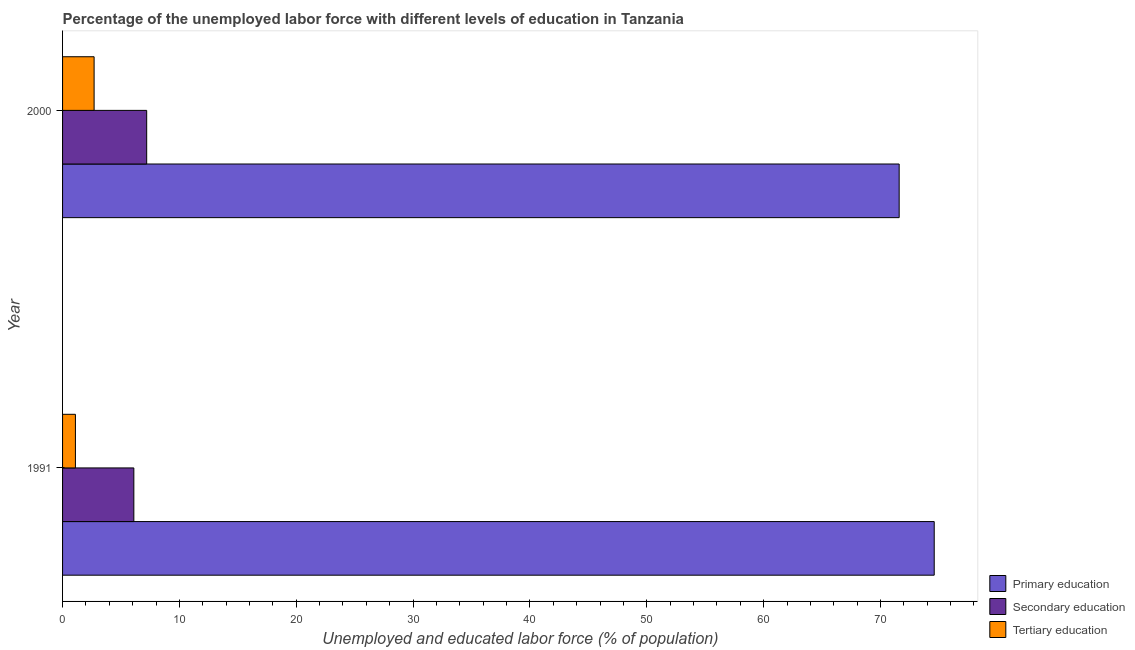How many different coloured bars are there?
Offer a very short reply. 3. How many groups of bars are there?
Make the answer very short. 2. Are the number of bars per tick equal to the number of legend labels?
Your answer should be compact. Yes. How many bars are there on the 2nd tick from the top?
Provide a succinct answer. 3. How many bars are there on the 1st tick from the bottom?
Give a very brief answer. 3. What is the percentage of labor force who received tertiary education in 2000?
Your response must be concise. 2.7. Across all years, what is the maximum percentage of labor force who received primary education?
Your answer should be compact. 74.6. Across all years, what is the minimum percentage of labor force who received tertiary education?
Your response must be concise. 1.1. What is the total percentage of labor force who received tertiary education in the graph?
Offer a very short reply. 3.8. What is the difference between the percentage of labor force who received primary education in 1991 and that in 2000?
Your response must be concise. 3. What is the difference between the percentage of labor force who received tertiary education in 1991 and the percentage of labor force who received secondary education in 2000?
Offer a very short reply. -6.1. What is the average percentage of labor force who received tertiary education per year?
Offer a terse response. 1.9. In the year 2000, what is the difference between the percentage of labor force who received primary education and percentage of labor force who received secondary education?
Offer a terse response. 64.4. In how many years, is the percentage of labor force who received secondary education greater than 18 %?
Provide a succinct answer. 0. What is the ratio of the percentage of labor force who received primary education in 1991 to that in 2000?
Give a very brief answer. 1.04. In how many years, is the percentage of labor force who received primary education greater than the average percentage of labor force who received primary education taken over all years?
Offer a terse response. 1. What does the 1st bar from the top in 2000 represents?
Your answer should be compact. Tertiary education. Is it the case that in every year, the sum of the percentage of labor force who received primary education and percentage of labor force who received secondary education is greater than the percentage of labor force who received tertiary education?
Your answer should be very brief. Yes. What is the difference between two consecutive major ticks on the X-axis?
Your answer should be very brief. 10. Are the values on the major ticks of X-axis written in scientific E-notation?
Make the answer very short. No. Does the graph contain grids?
Offer a terse response. No. Where does the legend appear in the graph?
Keep it short and to the point. Bottom right. How many legend labels are there?
Keep it short and to the point. 3. What is the title of the graph?
Your answer should be compact. Percentage of the unemployed labor force with different levels of education in Tanzania. Does "Wage workers" appear as one of the legend labels in the graph?
Your answer should be compact. No. What is the label or title of the X-axis?
Offer a very short reply. Unemployed and educated labor force (% of population). What is the label or title of the Y-axis?
Offer a very short reply. Year. What is the Unemployed and educated labor force (% of population) in Primary education in 1991?
Ensure brevity in your answer.  74.6. What is the Unemployed and educated labor force (% of population) of Secondary education in 1991?
Give a very brief answer. 6.1. What is the Unemployed and educated labor force (% of population) in Tertiary education in 1991?
Your answer should be compact. 1.1. What is the Unemployed and educated labor force (% of population) in Primary education in 2000?
Ensure brevity in your answer.  71.6. What is the Unemployed and educated labor force (% of population) in Secondary education in 2000?
Ensure brevity in your answer.  7.2. What is the Unemployed and educated labor force (% of population) of Tertiary education in 2000?
Provide a succinct answer. 2.7. Across all years, what is the maximum Unemployed and educated labor force (% of population) in Primary education?
Your response must be concise. 74.6. Across all years, what is the maximum Unemployed and educated labor force (% of population) of Secondary education?
Offer a terse response. 7.2. Across all years, what is the maximum Unemployed and educated labor force (% of population) of Tertiary education?
Keep it short and to the point. 2.7. Across all years, what is the minimum Unemployed and educated labor force (% of population) of Primary education?
Your answer should be very brief. 71.6. Across all years, what is the minimum Unemployed and educated labor force (% of population) in Secondary education?
Make the answer very short. 6.1. Across all years, what is the minimum Unemployed and educated labor force (% of population) in Tertiary education?
Make the answer very short. 1.1. What is the total Unemployed and educated labor force (% of population) in Primary education in the graph?
Make the answer very short. 146.2. What is the total Unemployed and educated labor force (% of population) of Tertiary education in the graph?
Your answer should be compact. 3.8. What is the difference between the Unemployed and educated labor force (% of population) in Primary education in 1991 and that in 2000?
Provide a succinct answer. 3. What is the difference between the Unemployed and educated labor force (% of population) in Secondary education in 1991 and that in 2000?
Your answer should be compact. -1.1. What is the difference between the Unemployed and educated labor force (% of population) in Tertiary education in 1991 and that in 2000?
Ensure brevity in your answer.  -1.6. What is the difference between the Unemployed and educated labor force (% of population) of Primary education in 1991 and the Unemployed and educated labor force (% of population) of Secondary education in 2000?
Your answer should be compact. 67.4. What is the difference between the Unemployed and educated labor force (% of population) of Primary education in 1991 and the Unemployed and educated labor force (% of population) of Tertiary education in 2000?
Offer a very short reply. 71.9. What is the average Unemployed and educated labor force (% of population) of Primary education per year?
Ensure brevity in your answer.  73.1. What is the average Unemployed and educated labor force (% of population) of Secondary education per year?
Offer a terse response. 6.65. In the year 1991, what is the difference between the Unemployed and educated labor force (% of population) of Primary education and Unemployed and educated labor force (% of population) of Secondary education?
Ensure brevity in your answer.  68.5. In the year 1991, what is the difference between the Unemployed and educated labor force (% of population) in Primary education and Unemployed and educated labor force (% of population) in Tertiary education?
Make the answer very short. 73.5. In the year 1991, what is the difference between the Unemployed and educated labor force (% of population) of Secondary education and Unemployed and educated labor force (% of population) of Tertiary education?
Ensure brevity in your answer.  5. In the year 2000, what is the difference between the Unemployed and educated labor force (% of population) of Primary education and Unemployed and educated labor force (% of population) of Secondary education?
Provide a succinct answer. 64.4. In the year 2000, what is the difference between the Unemployed and educated labor force (% of population) of Primary education and Unemployed and educated labor force (% of population) of Tertiary education?
Give a very brief answer. 68.9. In the year 2000, what is the difference between the Unemployed and educated labor force (% of population) of Secondary education and Unemployed and educated labor force (% of population) of Tertiary education?
Give a very brief answer. 4.5. What is the ratio of the Unemployed and educated labor force (% of population) of Primary education in 1991 to that in 2000?
Offer a very short reply. 1.04. What is the ratio of the Unemployed and educated labor force (% of population) in Secondary education in 1991 to that in 2000?
Your answer should be very brief. 0.85. What is the ratio of the Unemployed and educated labor force (% of population) in Tertiary education in 1991 to that in 2000?
Your response must be concise. 0.41. What is the difference between the highest and the lowest Unemployed and educated labor force (% of population) in Primary education?
Offer a terse response. 3. What is the difference between the highest and the lowest Unemployed and educated labor force (% of population) in Secondary education?
Your response must be concise. 1.1. What is the difference between the highest and the lowest Unemployed and educated labor force (% of population) of Tertiary education?
Give a very brief answer. 1.6. 